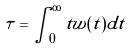<formula> <loc_0><loc_0><loc_500><loc_500>\tau = \int _ { 0 } ^ { \infty } t w ( t ) d t</formula> 